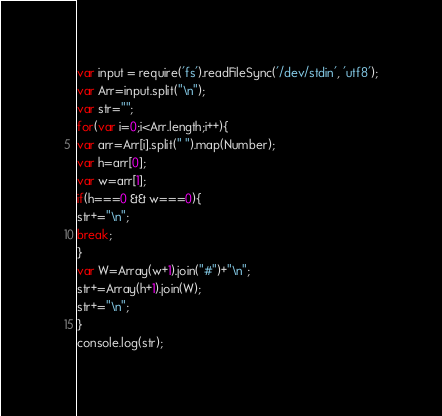Convert code to text. <code><loc_0><loc_0><loc_500><loc_500><_JavaScript_>var input = require('fs').readFileSync('/dev/stdin', 'utf8');
var Arr=input.split("\n");
var str="";
for(var i=0;i<Arr.length;i++){
var arr=Arr[i].split(" ").map(Number);
var h=arr[0];
var w=arr[1];
if(h===0 && w===0){
str+="\n";
break;
}
var W=Array(w+1).join("#")+"\n";
str+=Array(h+1).join(W);
str+="\n";
}
console.log(str);</code> 